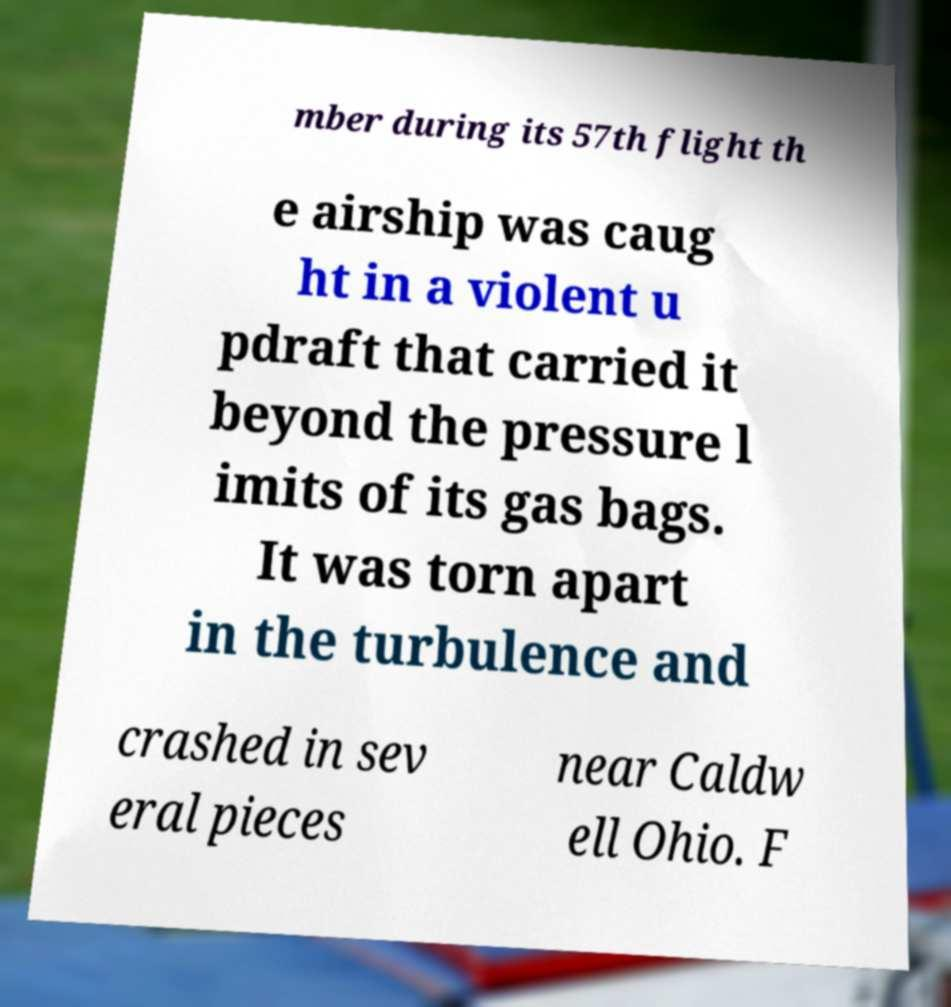Could you extract and type out the text from this image? mber during its 57th flight th e airship was caug ht in a violent u pdraft that carried it beyond the pressure l imits of its gas bags. It was torn apart in the turbulence and crashed in sev eral pieces near Caldw ell Ohio. F 